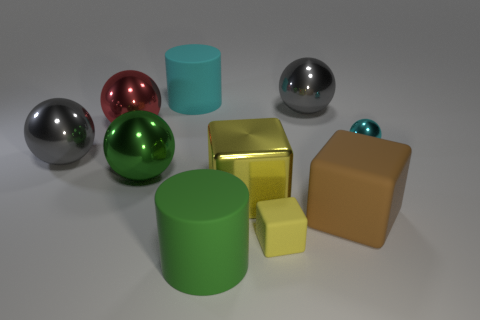Subtract all gray metallic balls. How many balls are left? 3 Subtract all blue cylinders. How many gray balls are left? 2 Subtract 1 spheres. How many spheres are left? 4 Subtract all green spheres. How many spheres are left? 4 Subtract all red cubes. Subtract all purple balls. How many cubes are left? 3 Subtract all blocks. How many objects are left? 7 Subtract all red objects. Subtract all gray shiny spheres. How many objects are left? 7 Add 4 large cyan matte things. How many large cyan matte things are left? 5 Add 7 red rubber things. How many red rubber things exist? 7 Subtract 0 brown balls. How many objects are left? 10 